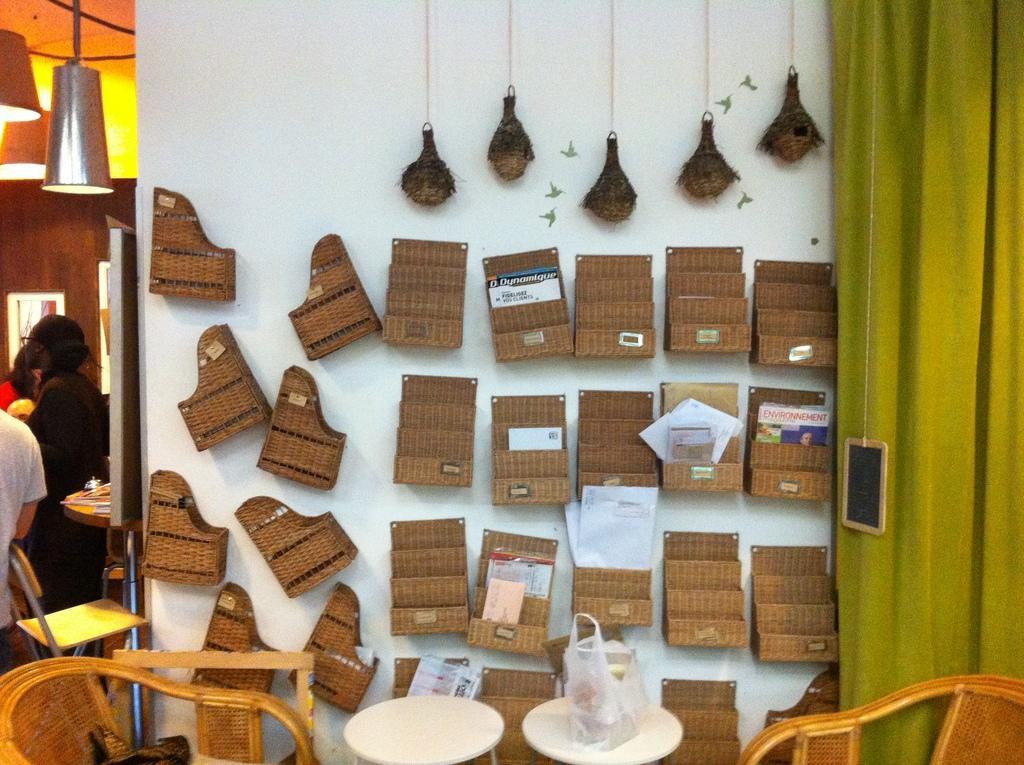How would you summarize this image in a sentence or two? In this image, There are some chairs in yellow color, There is a table on that there are two plates of white color, In the background there is a green color curtain and in the middle. There is a wall of white color and there are some brown color objects are placed, In the left side there are some people standing. 